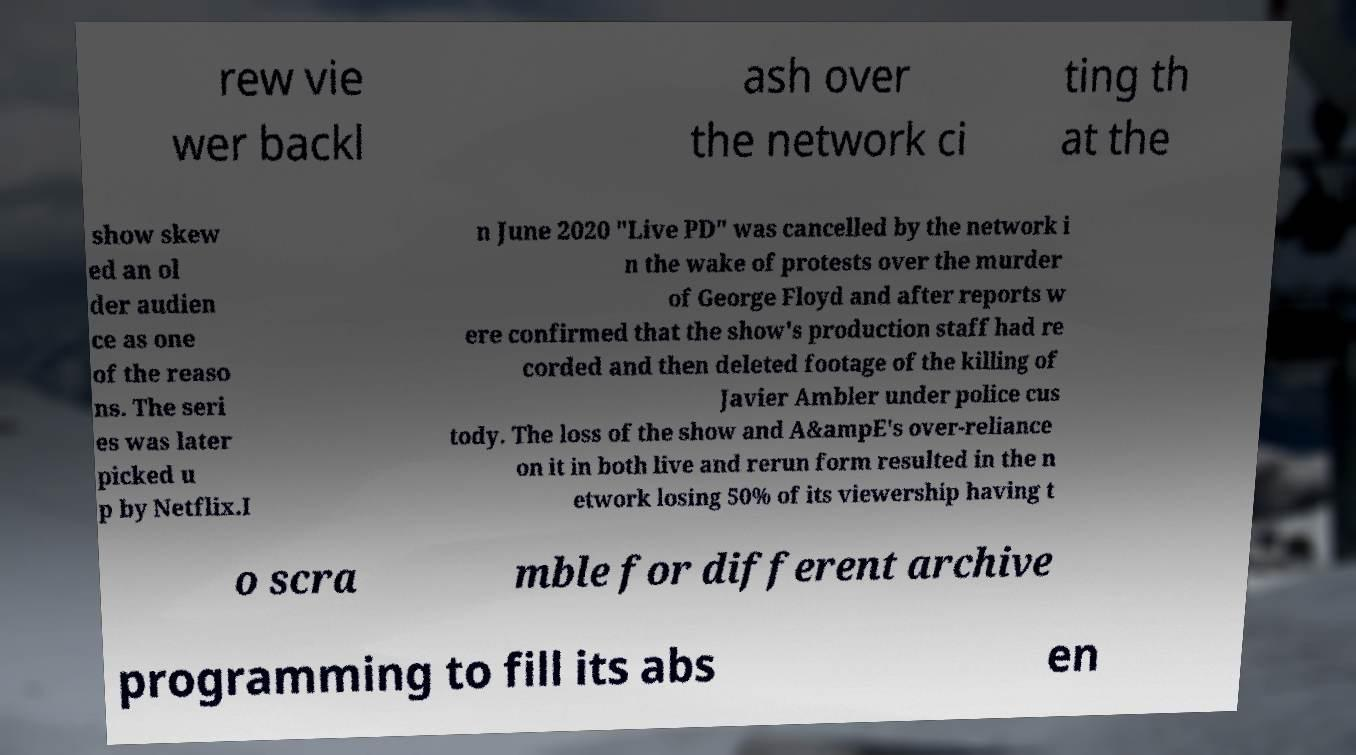Could you extract and type out the text from this image? rew vie wer backl ash over the network ci ting th at the show skew ed an ol der audien ce as one of the reaso ns. The seri es was later picked u p by Netflix.I n June 2020 "Live PD" was cancelled by the network i n the wake of protests over the murder of George Floyd and after reports w ere confirmed that the show's production staff had re corded and then deleted footage of the killing of Javier Ambler under police cus tody. The loss of the show and A&ampE's over-reliance on it in both live and rerun form resulted in the n etwork losing 50% of its viewership having t o scra mble for different archive programming to fill its abs en 